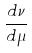Convert formula to latex. <formula><loc_0><loc_0><loc_500><loc_500>\frac { d \nu } { d \mu }</formula> 